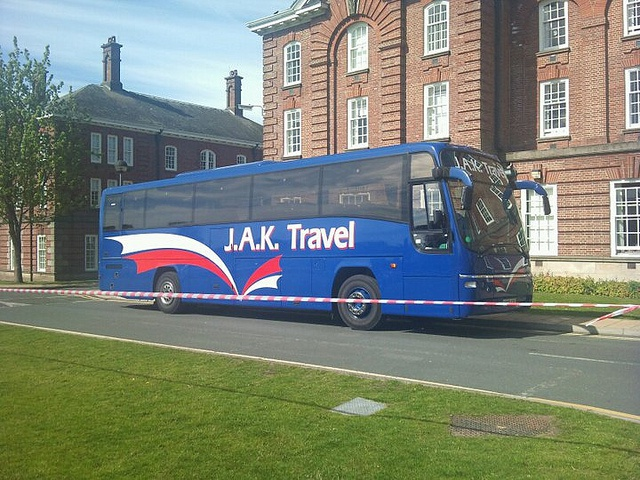Describe the objects in this image and their specific colors. I can see bus in lightblue, gray, blue, and white tones in this image. 